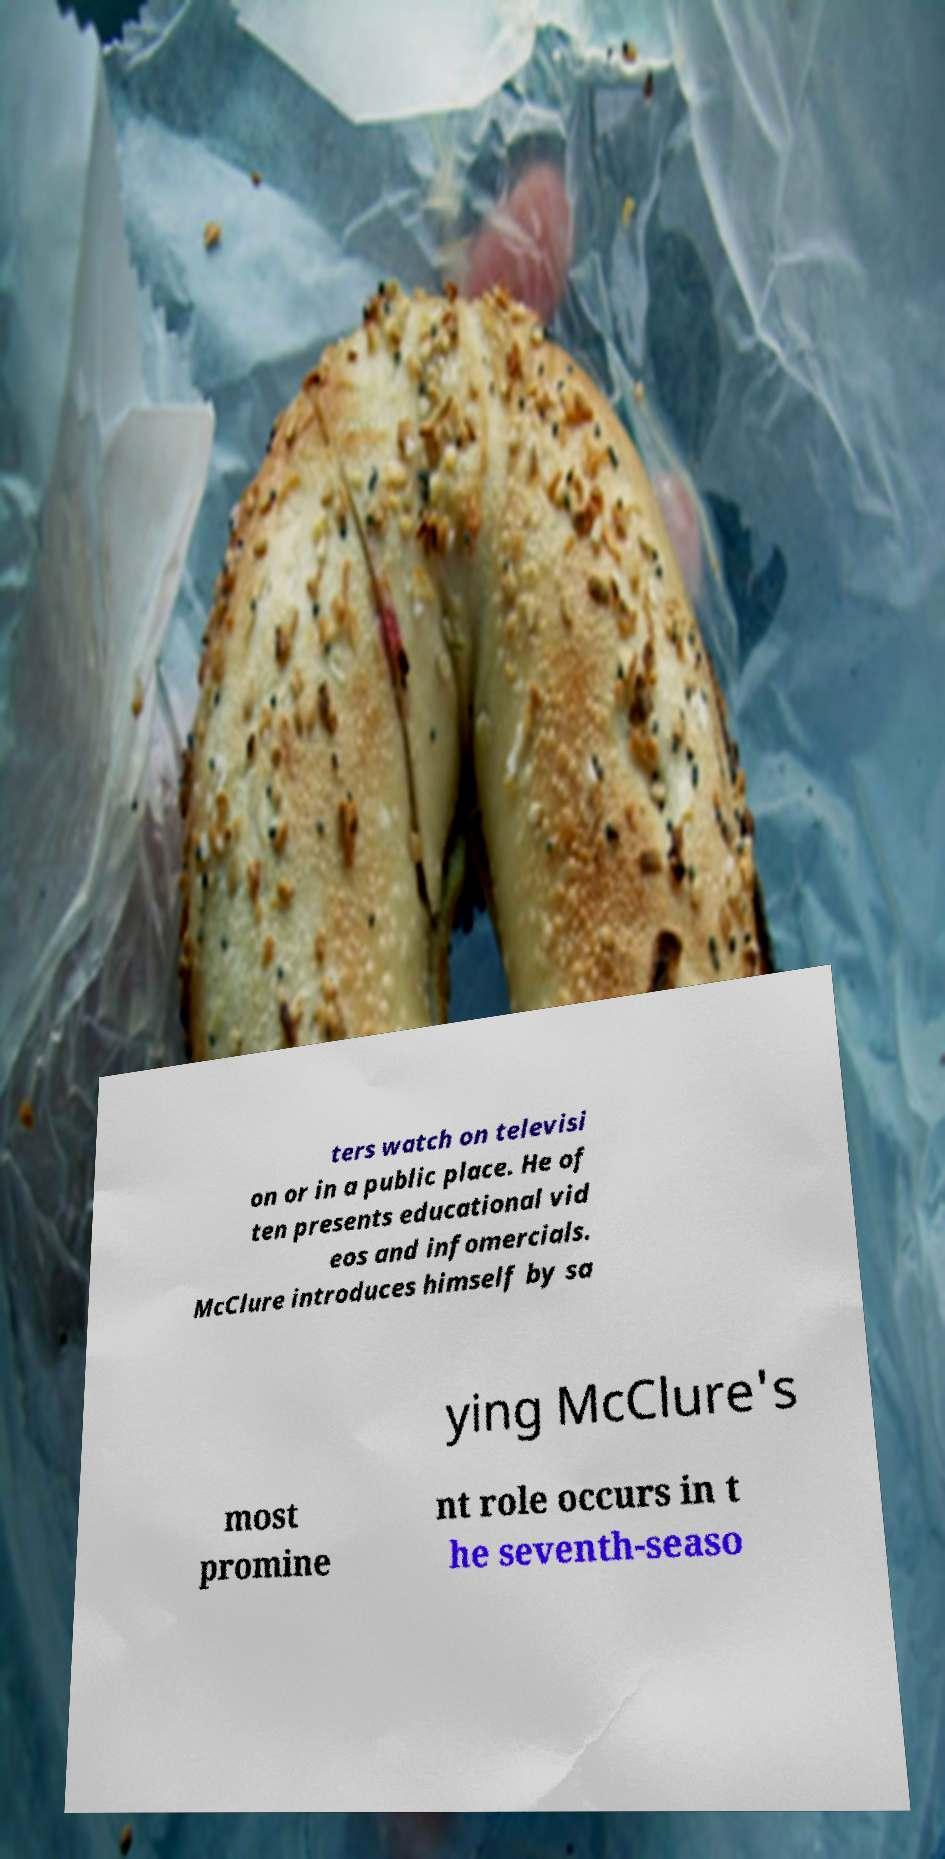Could you extract and type out the text from this image? ters watch on televisi on or in a public place. He of ten presents educational vid eos and infomercials. McClure introduces himself by sa ying McClure's most promine nt role occurs in t he seventh-seaso 